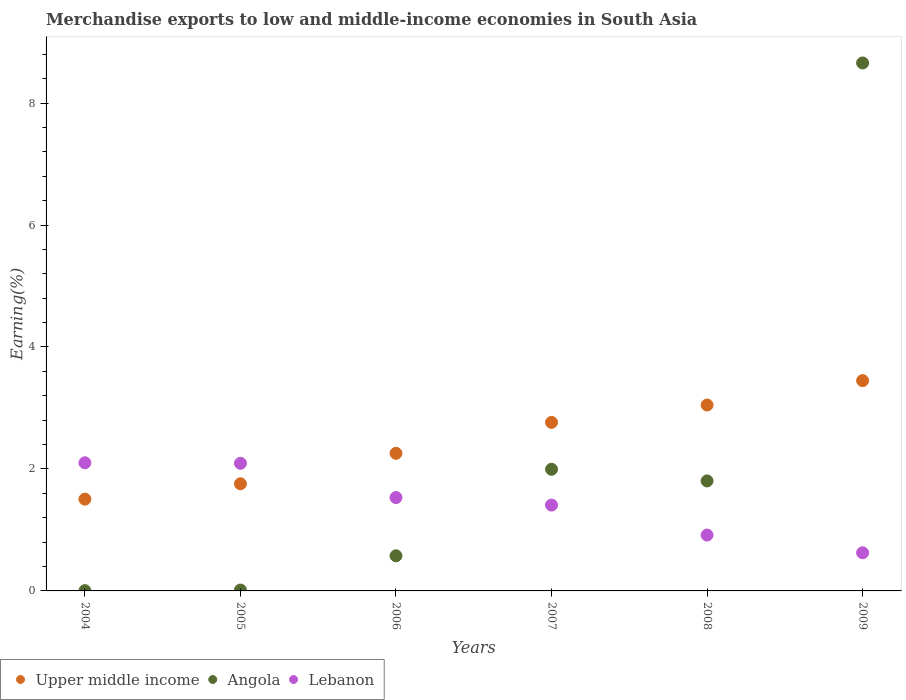How many different coloured dotlines are there?
Your answer should be very brief. 3. Is the number of dotlines equal to the number of legend labels?
Your answer should be very brief. Yes. What is the percentage of amount earned from merchandise exports in Upper middle income in 2007?
Your answer should be very brief. 2.76. Across all years, what is the maximum percentage of amount earned from merchandise exports in Angola?
Ensure brevity in your answer.  8.66. Across all years, what is the minimum percentage of amount earned from merchandise exports in Upper middle income?
Give a very brief answer. 1.5. In which year was the percentage of amount earned from merchandise exports in Lebanon minimum?
Your answer should be very brief. 2009. What is the total percentage of amount earned from merchandise exports in Angola in the graph?
Give a very brief answer. 13.05. What is the difference between the percentage of amount earned from merchandise exports in Upper middle income in 2007 and that in 2009?
Provide a succinct answer. -0.68. What is the difference between the percentage of amount earned from merchandise exports in Upper middle income in 2004 and the percentage of amount earned from merchandise exports in Lebanon in 2009?
Provide a succinct answer. 0.88. What is the average percentage of amount earned from merchandise exports in Lebanon per year?
Your answer should be very brief. 1.45. In the year 2005, what is the difference between the percentage of amount earned from merchandise exports in Lebanon and percentage of amount earned from merchandise exports in Upper middle income?
Provide a short and direct response. 0.34. What is the ratio of the percentage of amount earned from merchandise exports in Lebanon in 2004 to that in 2009?
Make the answer very short. 3.36. Is the percentage of amount earned from merchandise exports in Upper middle income in 2004 less than that in 2008?
Provide a short and direct response. Yes. Is the difference between the percentage of amount earned from merchandise exports in Lebanon in 2004 and 2005 greater than the difference between the percentage of amount earned from merchandise exports in Upper middle income in 2004 and 2005?
Offer a very short reply. Yes. What is the difference between the highest and the second highest percentage of amount earned from merchandise exports in Upper middle income?
Your response must be concise. 0.4. What is the difference between the highest and the lowest percentage of amount earned from merchandise exports in Upper middle income?
Give a very brief answer. 1.94. Is the sum of the percentage of amount earned from merchandise exports in Upper middle income in 2004 and 2008 greater than the maximum percentage of amount earned from merchandise exports in Angola across all years?
Provide a short and direct response. No. Is it the case that in every year, the sum of the percentage of amount earned from merchandise exports in Lebanon and percentage of amount earned from merchandise exports in Upper middle income  is greater than the percentage of amount earned from merchandise exports in Angola?
Keep it short and to the point. No. Does the percentage of amount earned from merchandise exports in Upper middle income monotonically increase over the years?
Provide a short and direct response. Yes. What is the difference between two consecutive major ticks on the Y-axis?
Your response must be concise. 2. Are the values on the major ticks of Y-axis written in scientific E-notation?
Offer a very short reply. No. Does the graph contain any zero values?
Give a very brief answer. No. How many legend labels are there?
Your response must be concise. 3. What is the title of the graph?
Provide a short and direct response. Merchandise exports to low and middle-income economies in South Asia. What is the label or title of the Y-axis?
Make the answer very short. Earning(%). What is the Earning(%) in Upper middle income in 2004?
Provide a succinct answer. 1.5. What is the Earning(%) of Angola in 2004?
Give a very brief answer. 0. What is the Earning(%) of Lebanon in 2004?
Your answer should be compact. 2.1. What is the Earning(%) of Upper middle income in 2005?
Your answer should be very brief. 1.76. What is the Earning(%) of Angola in 2005?
Provide a succinct answer. 0.01. What is the Earning(%) in Lebanon in 2005?
Your answer should be compact. 2.09. What is the Earning(%) of Upper middle income in 2006?
Ensure brevity in your answer.  2.26. What is the Earning(%) of Angola in 2006?
Keep it short and to the point. 0.58. What is the Earning(%) in Lebanon in 2006?
Provide a short and direct response. 1.53. What is the Earning(%) in Upper middle income in 2007?
Keep it short and to the point. 2.76. What is the Earning(%) in Angola in 2007?
Offer a very short reply. 1.99. What is the Earning(%) in Lebanon in 2007?
Your answer should be compact. 1.41. What is the Earning(%) of Upper middle income in 2008?
Offer a terse response. 3.05. What is the Earning(%) in Angola in 2008?
Your answer should be compact. 1.8. What is the Earning(%) of Lebanon in 2008?
Offer a very short reply. 0.92. What is the Earning(%) in Upper middle income in 2009?
Your answer should be very brief. 3.45. What is the Earning(%) in Angola in 2009?
Your response must be concise. 8.66. What is the Earning(%) of Lebanon in 2009?
Keep it short and to the point. 0.63. Across all years, what is the maximum Earning(%) of Upper middle income?
Make the answer very short. 3.45. Across all years, what is the maximum Earning(%) of Angola?
Your answer should be very brief. 8.66. Across all years, what is the maximum Earning(%) of Lebanon?
Give a very brief answer. 2.1. Across all years, what is the minimum Earning(%) of Upper middle income?
Provide a short and direct response. 1.5. Across all years, what is the minimum Earning(%) of Angola?
Make the answer very short. 0. Across all years, what is the minimum Earning(%) of Lebanon?
Your answer should be very brief. 0.63. What is the total Earning(%) of Upper middle income in the graph?
Your response must be concise. 14.78. What is the total Earning(%) in Angola in the graph?
Offer a very short reply. 13.05. What is the total Earning(%) in Lebanon in the graph?
Offer a terse response. 8.67. What is the difference between the Earning(%) of Upper middle income in 2004 and that in 2005?
Give a very brief answer. -0.25. What is the difference between the Earning(%) in Angola in 2004 and that in 2005?
Keep it short and to the point. -0.01. What is the difference between the Earning(%) in Lebanon in 2004 and that in 2005?
Your answer should be compact. 0.01. What is the difference between the Earning(%) of Upper middle income in 2004 and that in 2006?
Keep it short and to the point. -0.75. What is the difference between the Earning(%) in Angola in 2004 and that in 2006?
Your answer should be very brief. -0.57. What is the difference between the Earning(%) in Lebanon in 2004 and that in 2006?
Provide a succinct answer. 0.57. What is the difference between the Earning(%) of Upper middle income in 2004 and that in 2007?
Provide a short and direct response. -1.26. What is the difference between the Earning(%) of Angola in 2004 and that in 2007?
Your response must be concise. -1.99. What is the difference between the Earning(%) of Lebanon in 2004 and that in 2007?
Offer a terse response. 0.69. What is the difference between the Earning(%) of Upper middle income in 2004 and that in 2008?
Your response must be concise. -1.54. What is the difference between the Earning(%) in Angola in 2004 and that in 2008?
Ensure brevity in your answer.  -1.8. What is the difference between the Earning(%) in Lebanon in 2004 and that in 2008?
Keep it short and to the point. 1.18. What is the difference between the Earning(%) of Upper middle income in 2004 and that in 2009?
Give a very brief answer. -1.94. What is the difference between the Earning(%) in Angola in 2004 and that in 2009?
Make the answer very short. -8.65. What is the difference between the Earning(%) in Lebanon in 2004 and that in 2009?
Give a very brief answer. 1.48. What is the difference between the Earning(%) of Upper middle income in 2005 and that in 2006?
Make the answer very short. -0.5. What is the difference between the Earning(%) of Angola in 2005 and that in 2006?
Provide a short and direct response. -0.56. What is the difference between the Earning(%) in Lebanon in 2005 and that in 2006?
Your answer should be very brief. 0.56. What is the difference between the Earning(%) of Upper middle income in 2005 and that in 2007?
Provide a succinct answer. -1.01. What is the difference between the Earning(%) of Angola in 2005 and that in 2007?
Provide a short and direct response. -1.98. What is the difference between the Earning(%) in Lebanon in 2005 and that in 2007?
Make the answer very short. 0.69. What is the difference between the Earning(%) in Upper middle income in 2005 and that in 2008?
Provide a succinct answer. -1.29. What is the difference between the Earning(%) in Angola in 2005 and that in 2008?
Provide a succinct answer. -1.79. What is the difference between the Earning(%) of Lebanon in 2005 and that in 2008?
Offer a very short reply. 1.18. What is the difference between the Earning(%) in Upper middle income in 2005 and that in 2009?
Make the answer very short. -1.69. What is the difference between the Earning(%) in Angola in 2005 and that in 2009?
Your answer should be compact. -8.64. What is the difference between the Earning(%) in Lebanon in 2005 and that in 2009?
Your answer should be compact. 1.47. What is the difference between the Earning(%) of Upper middle income in 2006 and that in 2007?
Offer a very short reply. -0.51. What is the difference between the Earning(%) of Angola in 2006 and that in 2007?
Ensure brevity in your answer.  -1.42. What is the difference between the Earning(%) of Lebanon in 2006 and that in 2007?
Offer a terse response. 0.12. What is the difference between the Earning(%) of Upper middle income in 2006 and that in 2008?
Offer a terse response. -0.79. What is the difference between the Earning(%) of Angola in 2006 and that in 2008?
Provide a short and direct response. -1.23. What is the difference between the Earning(%) in Lebanon in 2006 and that in 2008?
Keep it short and to the point. 0.61. What is the difference between the Earning(%) of Upper middle income in 2006 and that in 2009?
Your answer should be compact. -1.19. What is the difference between the Earning(%) of Angola in 2006 and that in 2009?
Provide a succinct answer. -8.08. What is the difference between the Earning(%) in Lebanon in 2006 and that in 2009?
Your answer should be compact. 0.91. What is the difference between the Earning(%) of Upper middle income in 2007 and that in 2008?
Offer a terse response. -0.28. What is the difference between the Earning(%) of Angola in 2007 and that in 2008?
Provide a short and direct response. 0.19. What is the difference between the Earning(%) in Lebanon in 2007 and that in 2008?
Offer a very short reply. 0.49. What is the difference between the Earning(%) of Upper middle income in 2007 and that in 2009?
Provide a short and direct response. -0.68. What is the difference between the Earning(%) in Angola in 2007 and that in 2009?
Offer a terse response. -6.66. What is the difference between the Earning(%) in Lebanon in 2007 and that in 2009?
Your answer should be compact. 0.78. What is the difference between the Earning(%) in Upper middle income in 2008 and that in 2009?
Offer a very short reply. -0.4. What is the difference between the Earning(%) in Angola in 2008 and that in 2009?
Keep it short and to the point. -6.85. What is the difference between the Earning(%) in Lebanon in 2008 and that in 2009?
Provide a succinct answer. 0.29. What is the difference between the Earning(%) of Upper middle income in 2004 and the Earning(%) of Angola in 2005?
Your answer should be very brief. 1.49. What is the difference between the Earning(%) of Upper middle income in 2004 and the Earning(%) of Lebanon in 2005?
Make the answer very short. -0.59. What is the difference between the Earning(%) in Angola in 2004 and the Earning(%) in Lebanon in 2005?
Your response must be concise. -2.09. What is the difference between the Earning(%) of Upper middle income in 2004 and the Earning(%) of Angola in 2006?
Give a very brief answer. 0.93. What is the difference between the Earning(%) of Upper middle income in 2004 and the Earning(%) of Lebanon in 2006?
Ensure brevity in your answer.  -0.03. What is the difference between the Earning(%) in Angola in 2004 and the Earning(%) in Lebanon in 2006?
Your answer should be very brief. -1.53. What is the difference between the Earning(%) in Upper middle income in 2004 and the Earning(%) in Angola in 2007?
Make the answer very short. -0.49. What is the difference between the Earning(%) in Upper middle income in 2004 and the Earning(%) in Lebanon in 2007?
Offer a terse response. 0.1. What is the difference between the Earning(%) in Angola in 2004 and the Earning(%) in Lebanon in 2007?
Your answer should be compact. -1.4. What is the difference between the Earning(%) in Upper middle income in 2004 and the Earning(%) in Angola in 2008?
Provide a short and direct response. -0.3. What is the difference between the Earning(%) in Upper middle income in 2004 and the Earning(%) in Lebanon in 2008?
Ensure brevity in your answer.  0.59. What is the difference between the Earning(%) of Angola in 2004 and the Earning(%) of Lebanon in 2008?
Provide a succinct answer. -0.91. What is the difference between the Earning(%) in Upper middle income in 2004 and the Earning(%) in Angola in 2009?
Give a very brief answer. -7.15. What is the difference between the Earning(%) of Upper middle income in 2004 and the Earning(%) of Lebanon in 2009?
Your answer should be compact. 0.88. What is the difference between the Earning(%) of Angola in 2004 and the Earning(%) of Lebanon in 2009?
Provide a succinct answer. -0.62. What is the difference between the Earning(%) in Upper middle income in 2005 and the Earning(%) in Angola in 2006?
Offer a terse response. 1.18. What is the difference between the Earning(%) in Upper middle income in 2005 and the Earning(%) in Lebanon in 2006?
Offer a very short reply. 0.23. What is the difference between the Earning(%) in Angola in 2005 and the Earning(%) in Lebanon in 2006?
Give a very brief answer. -1.52. What is the difference between the Earning(%) of Upper middle income in 2005 and the Earning(%) of Angola in 2007?
Your answer should be very brief. -0.24. What is the difference between the Earning(%) of Upper middle income in 2005 and the Earning(%) of Lebanon in 2007?
Offer a terse response. 0.35. What is the difference between the Earning(%) in Angola in 2005 and the Earning(%) in Lebanon in 2007?
Offer a very short reply. -1.39. What is the difference between the Earning(%) of Upper middle income in 2005 and the Earning(%) of Angola in 2008?
Your answer should be compact. -0.05. What is the difference between the Earning(%) of Upper middle income in 2005 and the Earning(%) of Lebanon in 2008?
Provide a short and direct response. 0.84. What is the difference between the Earning(%) in Angola in 2005 and the Earning(%) in Lebanon in 2008?
Your answer should be compact. -0.9. What is the difference between the Earning(%) in Upper middle income in 2005 and the Earning(%) in Angola in 2009?
Provide a succinct answer. -6.9. What is the difference between the Earning(%) of Upper middle income in 2005 and the Earning(%) of Lebanon in 2009?
Provide a short and direct response. 1.13. What is the difference between the Earning(%) in Angola in 2005 and the Earning(%) in Lebanon in 2009?
Your answer should be compact. -0.61. What is the difference between the Earning(%) in Upper middle income in 2006 and the Earning(%) in Angola in 2007?
Your answer should be very brief. 0.26. What is the difference between the Earning(%) in Upper middle income in 2006 and the Earning(%) in Lebanon in 2007?
Your answer should be compact. 0.85. What is the difference between the Earning(%) in Angola in 2006 and the Earning(%) in Lebanon in 2007?
Your answer should be compact. -0.83. What is the difference between the Earning(%) of Upper middle income in 2006 and the Earning(%) of Angola in 2008?
Make the answer very short. 0.45. What is the difference between the Earning(%) of Upper middle income in 2006 and the Earning(%) of Lebanon in 2008?
Make the answer very short. 1.34. What is the difference between the Earning(%) in Angola in 2006 and the Earning(%) in Lebanon in 2008?
Your answer should be very brief. -0.34. What is the difference between the Earning(%) in Upper middle income in 2006 and the Earning(%) in Angola in 2009?
Ensure brevity in your answer.  -6.4. What is the difference between the Earning(%) in Upper middle income in 2006 and the Earning(%) in Lebanon in 2009?
Offer a terse response. 1.63. What is the difference between the Earning(%) of Angola in 2006 and the Earning(%) of Lebanon in 2009?
Provide a short and direct response. -0.05. What is the difference between the Earning(%) of Upper middle income in 2007 and the Earning(%) of Angola in 2008?
Make the answer very short. 0.96. What is the difference between the Earning(%) in Upper middle income in 2007 and the Earning(%) in Lebanon in 2008?
Provide a short and direct response. 1.85. What is the difference between the Earning(%) of Angola in 2007 and the Earning(%) of Lebanon in 2008?
Your answer should be compact. 1.08. What is the difference between the Earning(%) in Upper middle income in 2007 and the Earning(%) in Angola in 2009?
Provide a short and direct response. -5.89. What is the difference between the Earning(%) of Upper middle income in 2007 and the Earning(%) of Lebanon in 2009?
Make the answer very short. 2.14. What is the difference between the Earning(%) in Angola in 2007 and the Earning(%) in Lebanon in 2009?
Your answer should be very brief. 1.37. What is the difference between the Earning(%) in Upper middle income in 2008 and the Earning(%) in Angola in 2009?
Provide a short and direct response. -5.61. What is the difference between the Earning(%) in Upper middle income in 2008 and the Earning(%) in Lebanon in 2009?
Provide a succinct answer. 2.42. What is the difference between the Earning(%) of Angola in 2008 and the Earning(%) of Lebanon in 2009?
Provide a succinct answer. 1.18. What is the average Earning(%) of Upper middle income per year?
Provide a short and direct response. 2.46. What is the average Earning(%) in Angola per year?
Give a very brief answer. 2.18. What is the average Earning(%) in Lebanon per year?
Your response must be concise. 1.45. In the year 2004, what is the difference between the Earning(%) of Upper middle income and Earning(%) of Angola?
Provide a succinct answer. 1.5. In the year 2004, what is the difference between the Earning(%) in Upper middle income and Earning(%) in Lebanon?
Offer a terse response. -0.6. In the year 2004, what is the difference between the Earning(%) in Angola and Earning(%) in Lebanon?
Your response must be concise. -2.1. In the year 2005, what is the difference between the Earning(%) of Upper middle income and Earning(%) of Angola?
Keep it short and to the point. 1.74. In the year 2005, what is the difference between the Earning(%) of Upper middle income and Earning(%) of Lebanon?
Your answer should be very brief. -0.34. In the year 2005, what is the difference between the Earning(%) in Angola and Earning(%) in Lebanon?
Give a very brief answer. -2.08. In the year 2006, what is the difference between the Earning(%) of Upper middle income and Earning(%) of Angola?
Provide a succinct answer. 1.68. In the year 2006, what is the difference between the Earning(%) of Upper middle income and Earning(%) of Lebanon?
Give a very brief answer. 0.73. In the year 2006, what is the difference between the Earning(%) of Angola and Earning(%) of Lebanon?
Offer a terse response. -0.96. In the year 2007, what is the difference between the Earning(%) in Upper middle income and Earning(%) in Angola?
Provide a short and direct response. 0.77. In the year 2007, what is the difference between the Earning(%) in Upper middle income and Earning(%) in Lebanon?
Keep it short and to the point. 1.36. In the year 2007, what is the difference between the Earning(%) in Angola and Earning(%) in Lebanon?
Provide a short and direct response. 0.59. In the year 2008, what is the difference between the Earning(%) in Upper middle income and Earning(%) in Angola?
Offer a terse response. 1.24. In the year 2008, what is the difference between the Earning(%) in Upper middle income and Earning(%) in Lebanon?
Your answer should be compact. 2.13. In the year 2008, what is the difference between the Earning(%) of Angola and Earning(%) of Lebanon?
Provide a short and direct response. 0.89. In the year 2009, what is the difference between the Earning(%) in Upper middle income and Earning(%) in Angola?
Keep it short and to the point. -5.21. In the year 2009, what is the difference between the Earning(%) in Upper middle income and Earning(%) in Lebanon?
Provide a succinct answer. 2.82. In the year 2009, what is the difference between the Earning(%) in Angola and Earning(%) in Lebanon?
Your answer should be compact. 8.03. What is the ratio of the Earning(%) of Upper middle income in 2004 to that in 2005?
Make the answer very short. 0.86. What is the ratio of the Earning(%) in Angola in 2004 to that in 2005?
Keep it short and to the point. 0.31. What is the ratio of the Earning(%) in Lebanon in 2004 to that in 2005?
Provide a short and direct response. 1. What is the ratio of the Earning(%) in Upper middle income in 2004 to that in 2006?
Keep it short and to the point. 0.67. What is the ratio of the Earning(%) of Angola in 2004 to that in 2006?
Your response must be concise. 0.01. What is the ratio of the Earning(%) in Lebanon in 2004 to that in 2006?
Your answer should be very brief. 1.37. What is the ratio of the Earning(%) in Upper middle income in 2004 to that in 2007?
Your answer should be compact. 0.54. What is the ratio of the Earning(%) of Angola in 2004 to that in 2007?
Offer a terse response. 0. What is the ratio of the Earning(%) in Lebanon in 2004 to that in 2007?
Your answer should be compact. 1.49. What is the ratio of the Earning(%) of Upper middle income in 2004 to that in 2008?
Provide a short and direct response. 0.49. What is the ratio of the Earning(%) in Angola in 2004 to that in 2008?
Keep it short and to the point. 0. What is the ratio of the Earning(%) of Lebanon in 2004 to that in 2008?
Keep it short and to the point. 2.29. What is the ratio of the Earning(%) in Upper middle income in 2004 to that in 2009?
Your answer should be compact. 0.44. What is the ratio of the Earning(%) of Lebanon in 2004 to that in 2009?
Ensure brevity in your answer.  3.36. What is the ratio of the Earning(%) in Upper middle income in 2005 to that in 2006?
Ensure brevity in your answer.  0.78. What is the ratio of the Earning(%) of Angola in 2005 to that in 2006?
Provide a succinct answer. 0.03. What is the ratio of the Earning(%) of Lebanon in 2005 to that in 2006?
Provide a succinct answer. 1.37. What is the ratio of the Earning(%) in Upper middle income in 2005 to that in 2007?
Make the answer very short. 0.64. What is the ratio of the Earning(%) of Angola in 2005 to that in 2007?
Offer a terse response. 0.01. What is the ratio of the Earning(%) in Lebanon in 2005 to that in 2007?
Your answer should be very brief. 1.49. What is the ratio of the Earning(%) of Upper middle income in 2005 to that in 2008?
Give a very brief answer. 0.58. What is the ratio of the Earning(%) of Angola in 2005 to that in 2008?
Your response must be concise. 0.01. What is the ratio of the Earning(%) of Lebanon in 2005 to that in 2008?
Give a very brief answer. 2.28. What is the ratio of the Earning(%) of Upper middle income in 2005 to that in 2009?
Offer a terse response. 0.51. What is the ratio of the Earning(%) of Angola in 2005 to that in 2009?
Provide a succinct answer. 0. What is the ratio of the Earning(%) of Lebanon in 2005 to that in 2009?
Ensure brevity in your answer.  3.35. What is the ratio of the Earning(%) of Upper middle income in 2006 to that in 2007?
Provide a short and direct response. 0.82. What is the ratio of the Earning(%) of Angola in 2006 to that in 2007?
Your answer should be very brief. 0.29. What is the ratio of the Earning(%) in Lebanon in 2006 to that in 2007?
Make the answer very short. 1.09. What is the ratio of the Earning(%) of Upper middle income in 2006 to that in 2008?
Your response must be concise. 0.74. What is the ratio of the Earning(%) in Angola in 2006 to that in 2008?
Make the answer very short. 0.32. What is the ratio of the Earning(%) of Lebanon in 2006 to that in 2008?
Keep it short and to the point. 1.67. What is the ratio of the Earning(%) in Upper middle income in 2006 to that in 2009?
Offer a very short reply. 0.65. What is the ratio of the Earning(%) in Angola in 2006 to that in 2009?
Your response must be concise. 0.07. What is the ratio of the Earning(%) in Lebanon in 2006 to that in 2009?
Offer a very short reply. 2.45. What is the ratio of the Earning(%) of Upper middle income in 2007 to that in 2008?
Offer a terse response. 0.91. What is the ratio of the Earning(%) of Angola in 2007 to that in 2008?
Your answer should be compact. 1.11. What is the ratio of the Earning(%) in Lebanon in 2007 to that in 2008?
Your answer should be very brief. 1.54. What is the ratio of the Earning(%) in Upper middle income in 2007 to that in 2009?
Offer a very short reply. 0.8. What is the ratio of the Earning(%) of Angola in 2007 to that in 2009?
Give a very brief answer. 0.23. What is the ratio of the Earning(%) in Lebanon in 2007 to that in 2009?
Provide a succinct answer. 2.25. What is the ratio of the Earning(%) of Upper middle income in 2008 to that in 2009?
Offer a terse response. 0.88. What is the ratio of the Earning(%) in Angola in 2008 to that in 2009?
Your answer should be very brief. 0.21. What is the ratio of the Earning(%) of Lebanon in 2008 to that in 2009?
Make the answer very short. 1.47. What is the difference between the highest and the second highest Earning(%) in Upper middle income?
Keep it short and to the point. 0.4. What is the difference between the highest and the second highest Earning(%) of Angola?
Make the answer very short. 6.66. What is the difference between the highest and the second highest Earning(%) in Lebanon?
Make the answer very short. 0.01. What is the difference between the highest and the lowest Earning(%) in Upper middle income?
Keep it short and to the point. 1.94. What is the difference between the highest and the lowest Earning(%) in Angola?
Your answer should be very brief. 8.65. What is the difference between the highest and the lowest Earning(%) of Lebanon?
Your answer should be compact. 1.48. 